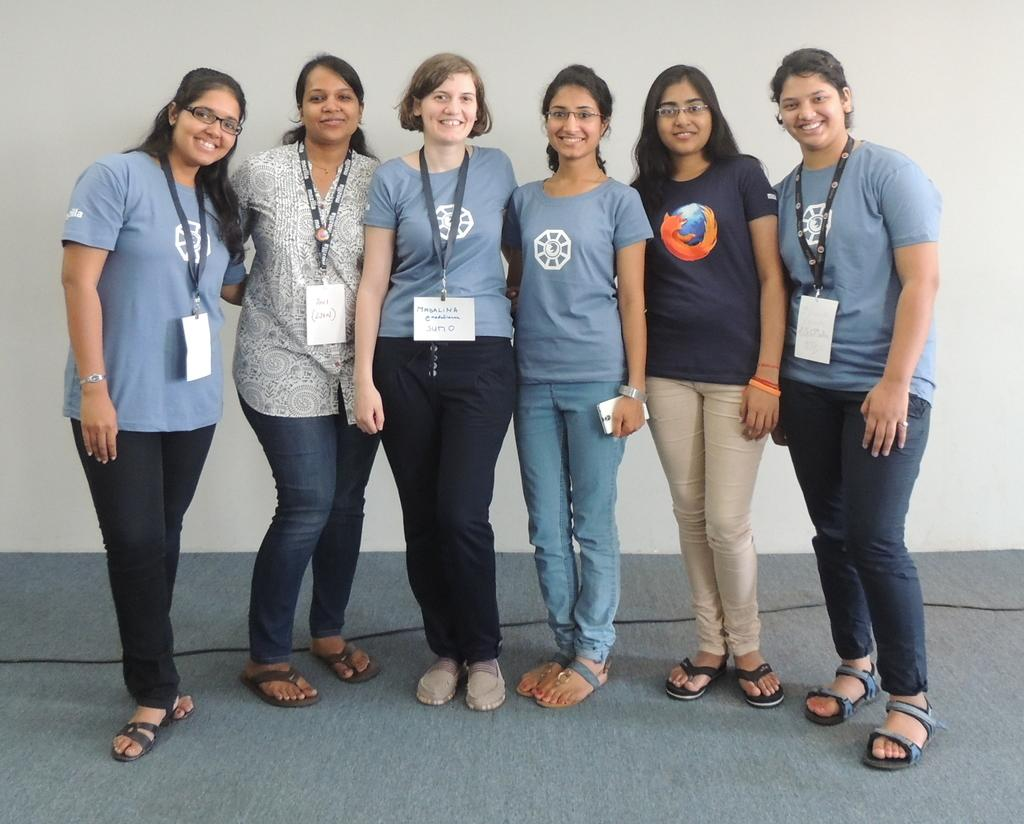How many women are present in the image? There are six women standing in the image. Can you describe the facial expression of one of the women? One of the women is smiling. What is the smiling woman wearing? The smiling woman is wearing a T-shirt. What can be seen in the background of the image? There is a wall in the background of the image. What type of object is on the floor in the image? There is a black color wire on the floor in the image. What type of jar is being used for magic tricks in the image? There is no jar or magic tricks present in the image. What type of shoes are the women wearing in the image? The provided facts do not mention the type of shoes the women are wearing in the image. 